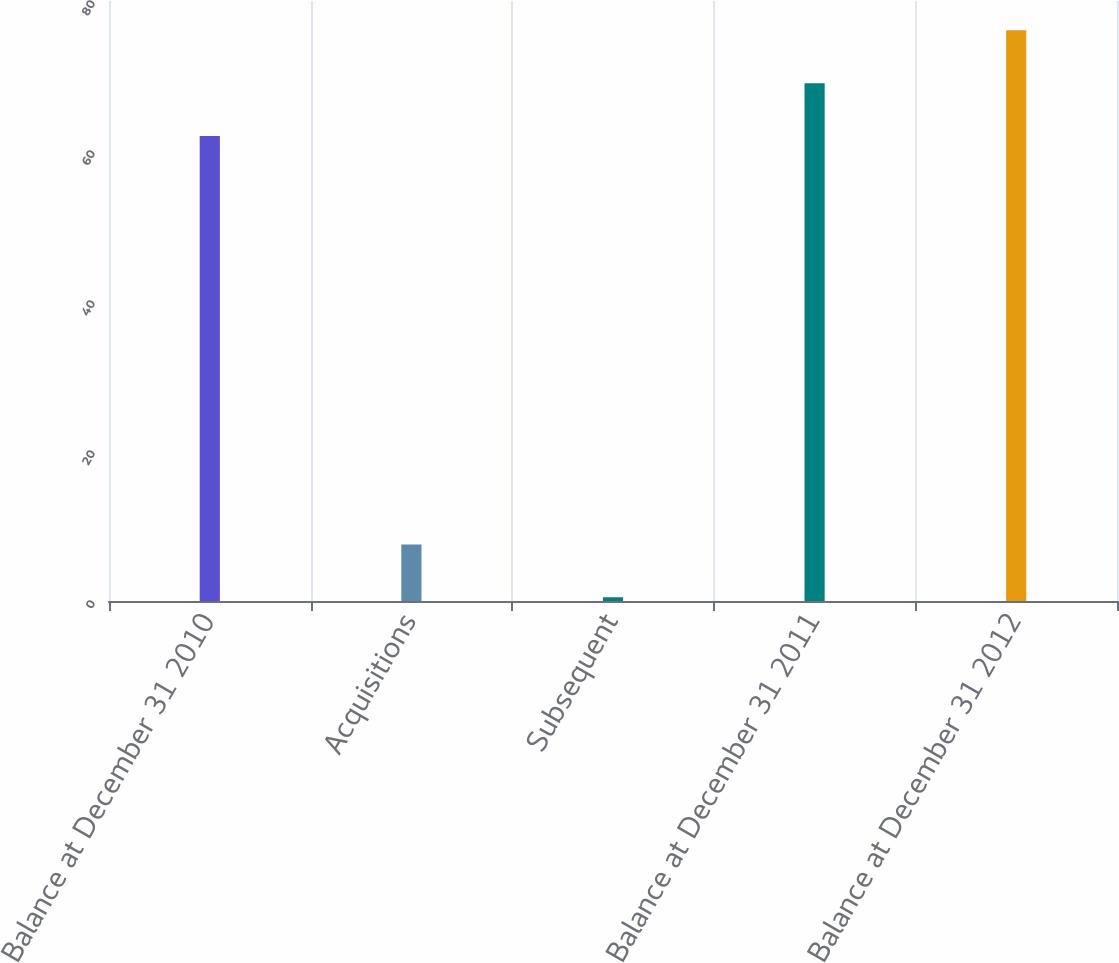Convert chart to OTSL. <chart><loc_0><loc_0><loc_500><loc_500><bar_chart><fcel>Balance at December 31 2010<fcel>Acquisitions<fcel>Subsequent<fcel>Balance at December 31 2011<fcel>Balance at December 31 2012<nl><fcel>62<fcel>7.55<fcel>0.5<fcel>69.05<fcel>76.1<nl></chart> 